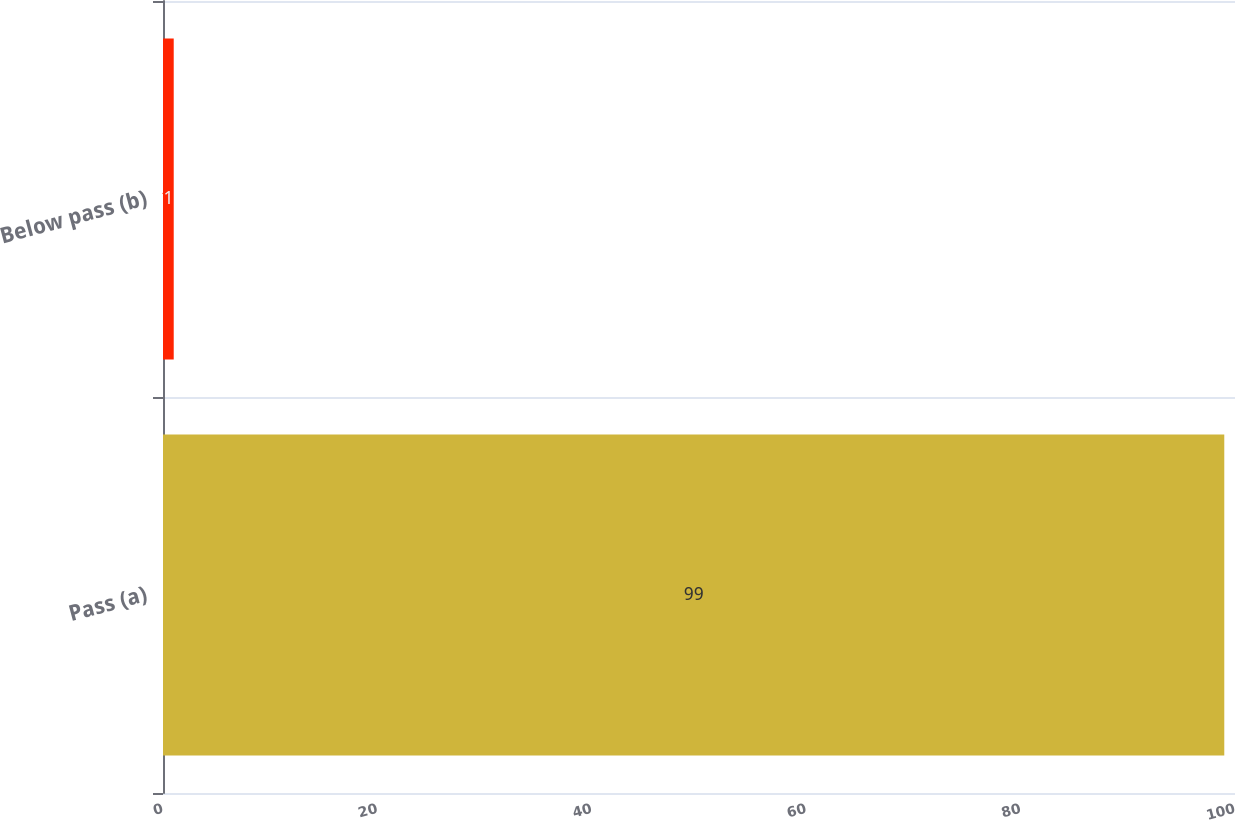<chart> <loc_0><loc_0><loc_500><loc_500><bar_chart><fcel>Pass (a)<fcel>Below pass (b)<nl><fcel>99<fcel>1<nl></chart> 